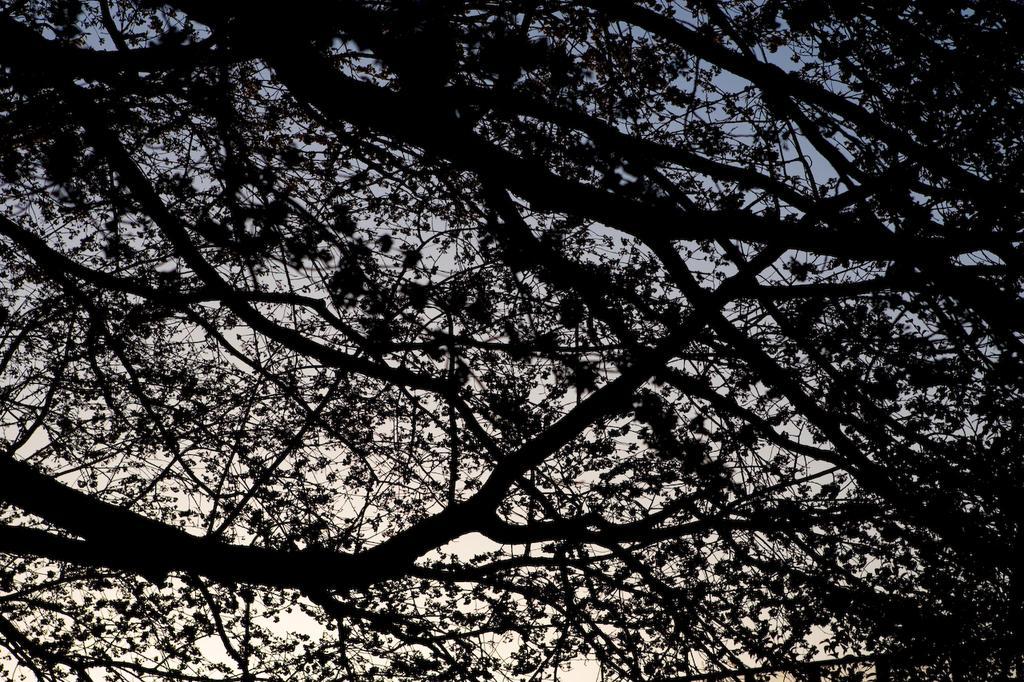Describe this image in one or two sentences. In this picture I can see tree branches and a cloudy sky. 